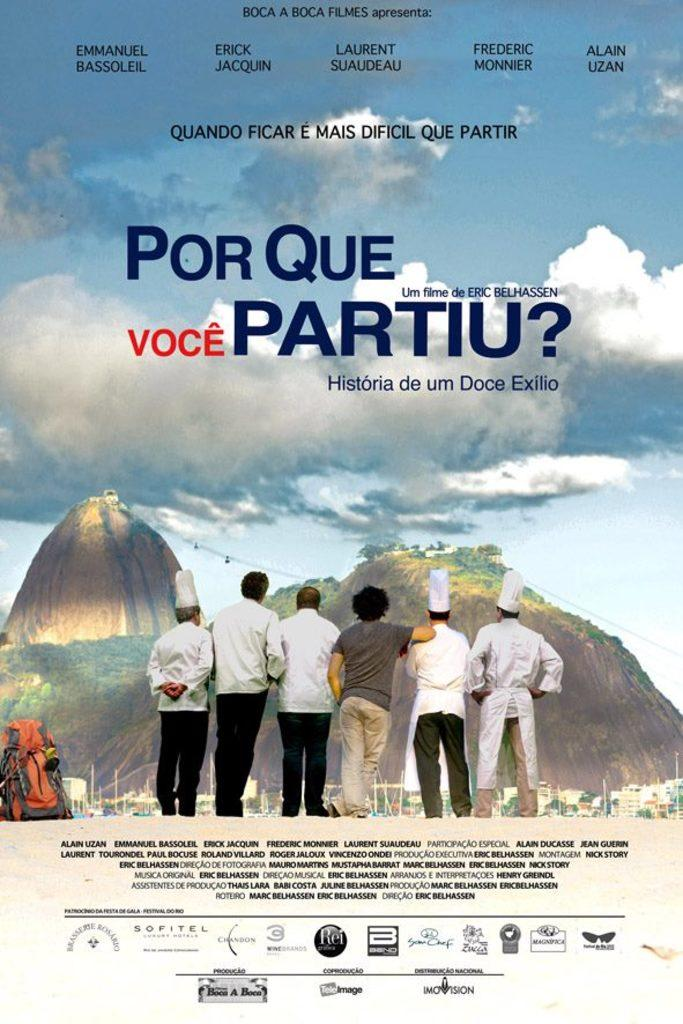<image>
Render a clear and concise summary of the photo. poster for the film Por Que Voce partiu with six different men on the bottom. 